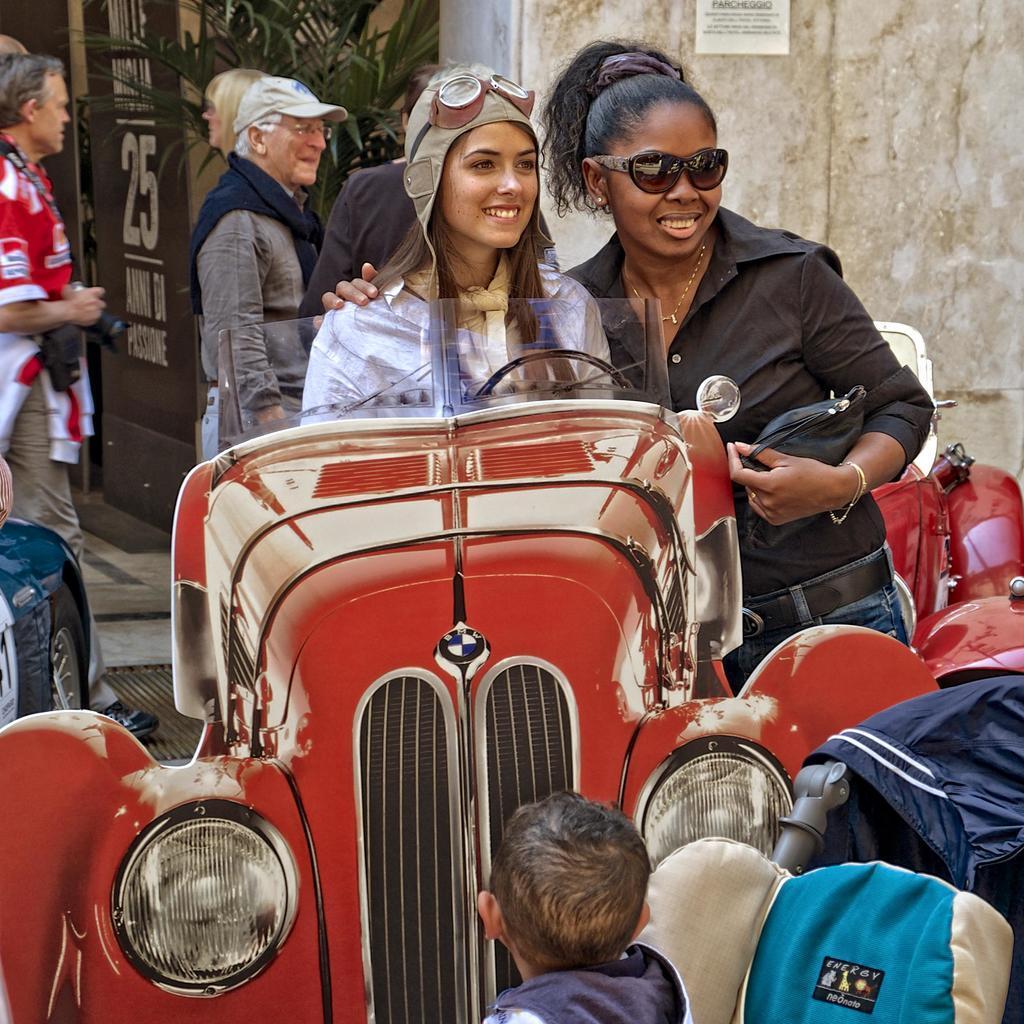Describe this image in one or two sentences. there are many people in this image. 2 people are standing near a vintage car. behind them there are plants 